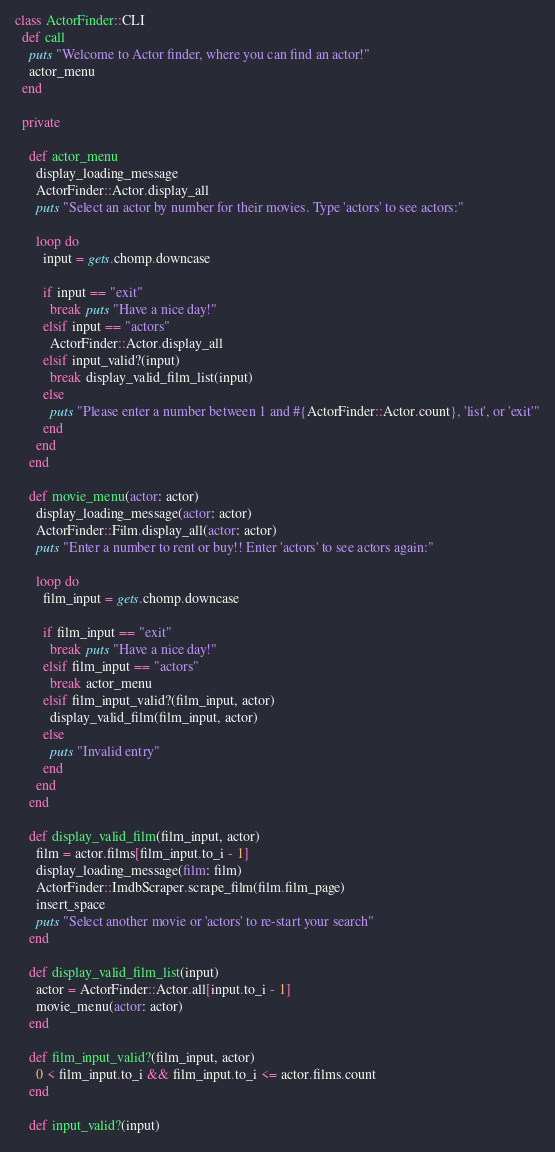<code> <loc_0><loc_0><loc_500><loc_500><_Ruby_>class ActorFinder::CLI
  def call
    puts "Welcome to Actor finder, where you can find an actor!"
    actor_menu
  end

  private

    def actor_menu
      display_loading_message
      ActorFinder::Actor.display_all
      puts "Select an actor by number for their movies. Type 'actors' to see actors:"

      loop do
        input = gets.chomp.downcase

        if input == "exit"
          break puts "Have a nice day!"
        elsif input == "actors"
          ActorFinder::Actor.display_all
        elsif input_valid?(input)
          break display_valid_film_list(input)
        else
          puts "Please enter a number between 1 and #{ActorFinder::Actor.count}, 'list', or 'exit'"
        end
      end
    end

    def movie_menu(actor: actor)
      display_loading_message(actor: actor)
      ActorFinder::Film.display_all(actor: actor)
      puts "Enter a number to rent or buy!! Enter 'actors' to see actors again:"

      loop do
        film_input = gets.chomp.downcase

        if film_input == "exit"
          break puts "Have a nice day!"
        elsif film_input == "actors"
          break actor_menu
        elsif film_input_valid?(film_input, actor)
          display_valid_film(film_input, actor)
        else
          puts "Invalid entry"
        end
      end
    end

    def display_valid_film(film_input, actor)
      film = actor.films[film_input.to_i - 1]
      display_loading_message(film: film)
      ActorFinder::ImdbScraper.scrape_film(film.film_page)
      insert_space
      puts "Select another movie or 'actors' to re-start your search"
    end

    def display_valid_film_list(input)
      actor = ActorFinder::Actor.all[input.to_i - 1]
      movie_menu(actor: actor)
    end

    def film_input_valid?(film_input, actor)
      0 < film_input.to_i && film_input.to_i <= actor.films.count
    end

    def input_valid?(input)</code> 